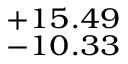<formula> <loc_0><loc_0><loc_500><loc_500>^ { + 1 5 . 4 9 } _ { - 1 0 . 3 3 }</formula> 